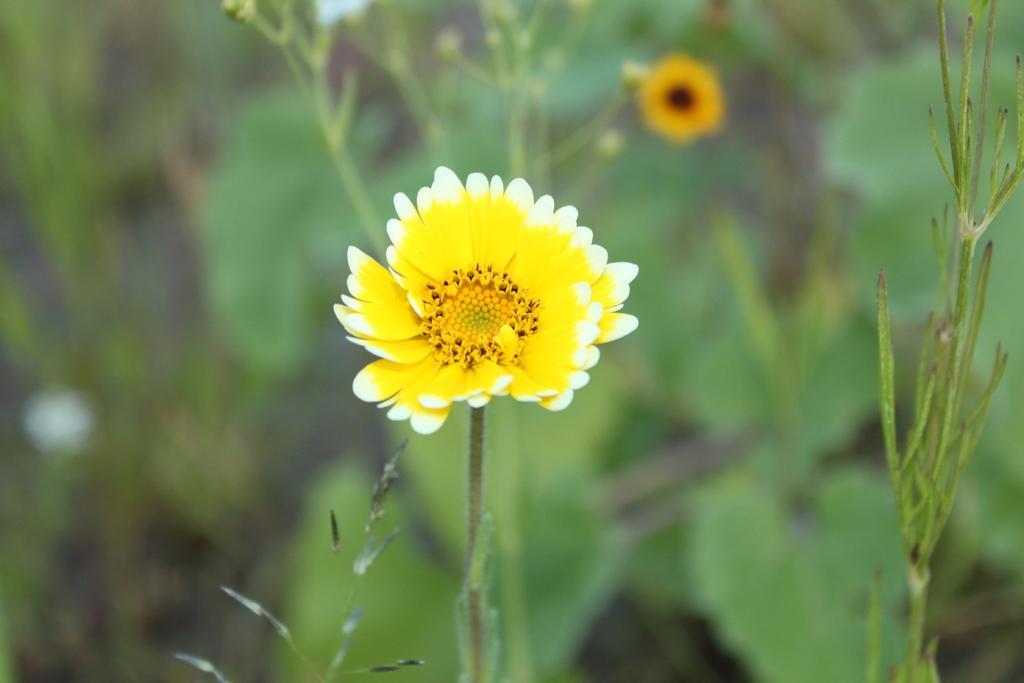In one or two sentences, can you explain what this image depicts? In the picture we can see a flower in a plant and behind it, we can see some plants which are not clearly visible. 